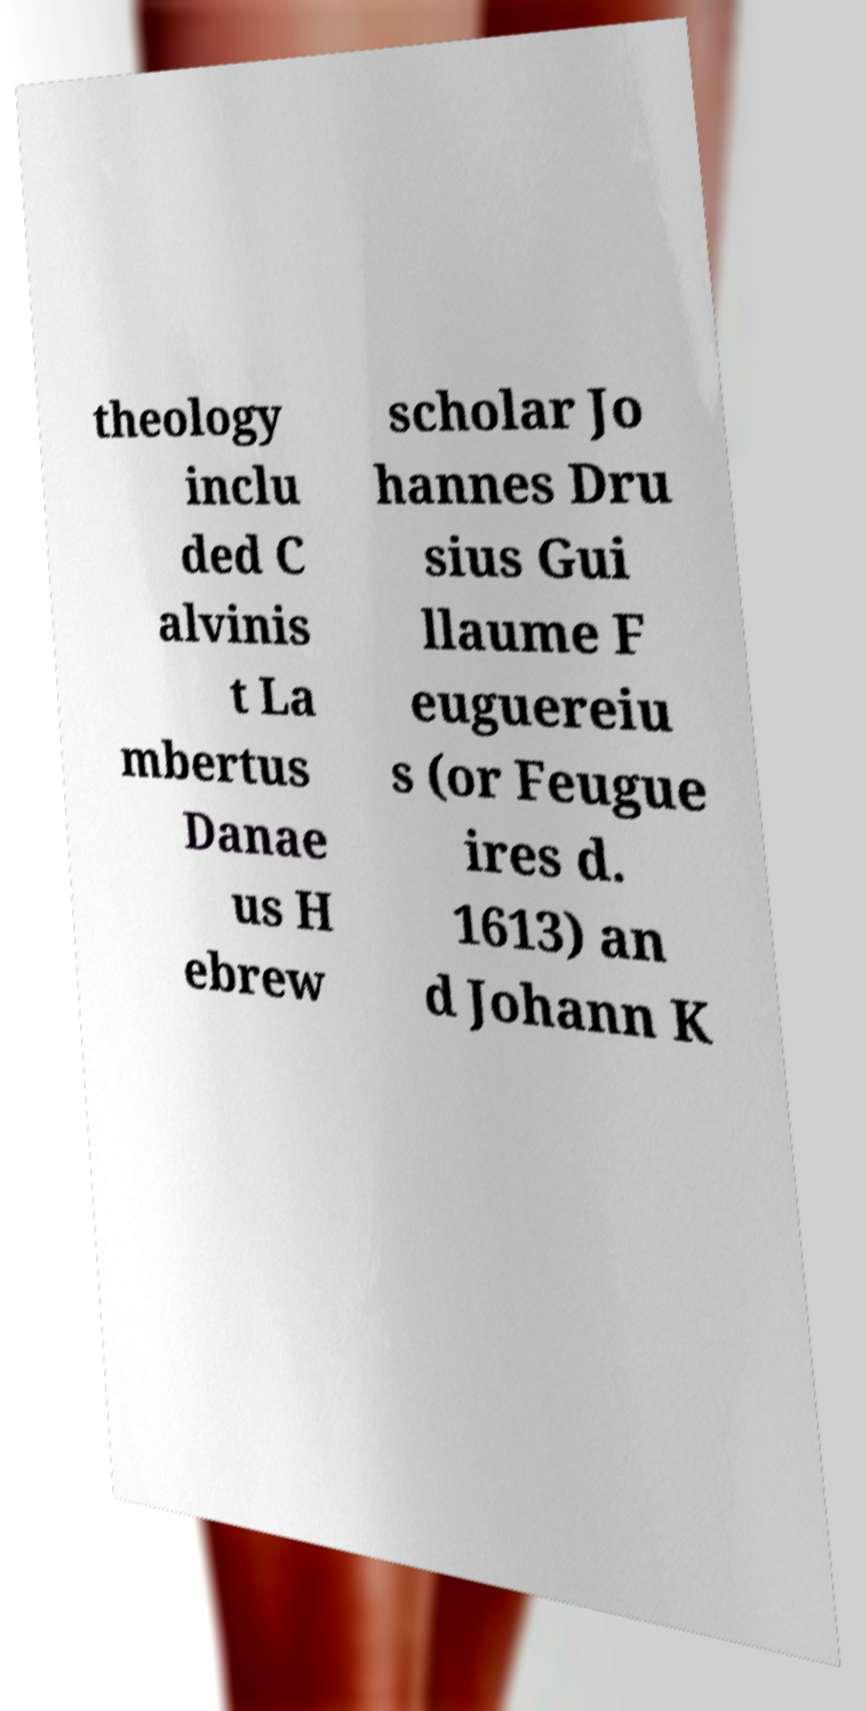Please read and relay the text visible in this image. What does it say? theology inclu ded C alvinis t La mbertus Danae us H ebrew scholar Jo hannes Dru sius Gui llaume F euguereiu s (or Feugue ires d. 1613) an d Johann K 